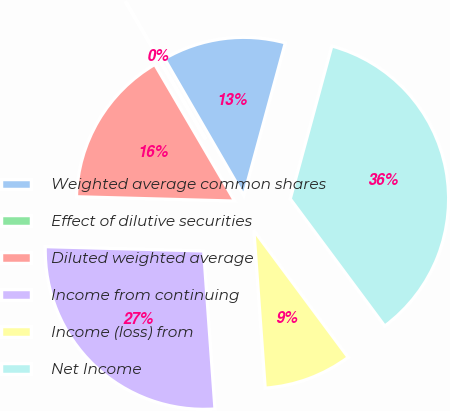Convert chart to OTSL. <chart><loc_0><loc_0><loc_500><loc_500><pie_chart><fcel>Weighted average common shares<fcel>Effect of dilutive securities<fcel>Diluted weighted average<fcel>Income from continuing<fcel>Income (loss) from<fcel>Net Income<nl><fcel>12.58%<fcel>0.07%<fcel>16.14%<fcel>26.57%<fcel>9.03%<fcel>35.6%<nl></chart> 